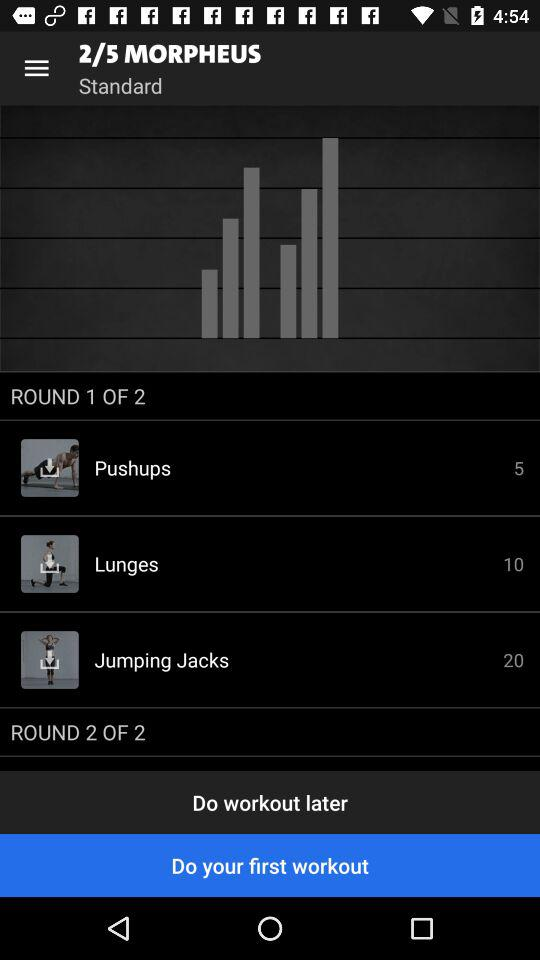What is the total number of rounds in "MORPHEUS"? The total number of rounds in "MORPHEUS" is 5. 